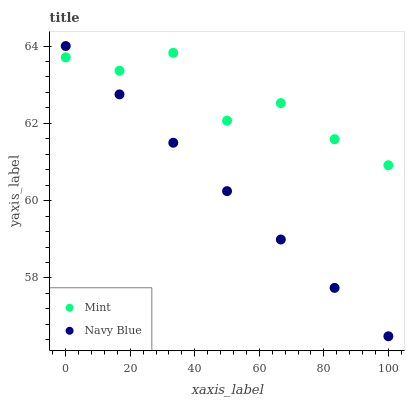Does Navy Blue have the minimum area under the curve?
Answer yes or no. Yes. Does Mint have the maximum area under the curve?
Answer yes or no. Yes. Does Mint have the minimum area under the curve?
Answer yes or no. No. Is Navy Blue the smoothest?
Answer yes or no. Yes. Is Mint the roughest?
Answer yes or no. Yes. Is Mint the smoothest?
Answer yes or no. No. Does Navy Blue have the lowest value?
Answer yes or no. Yes. Does Mint have the lowest value?
Answer yes or no. No. Does Navy Blue have the highest value?
Answer yes or no. Yes. Does Mint have the highest value?
Answer yes or no. No. Does Navy Blue intersect Mint?
Answer yes or no. Yes. Is Navy Blue less than Mint?
Answer yes or no. No. Is Navy Blue greater than Mint?
Answer yes or no. No. 